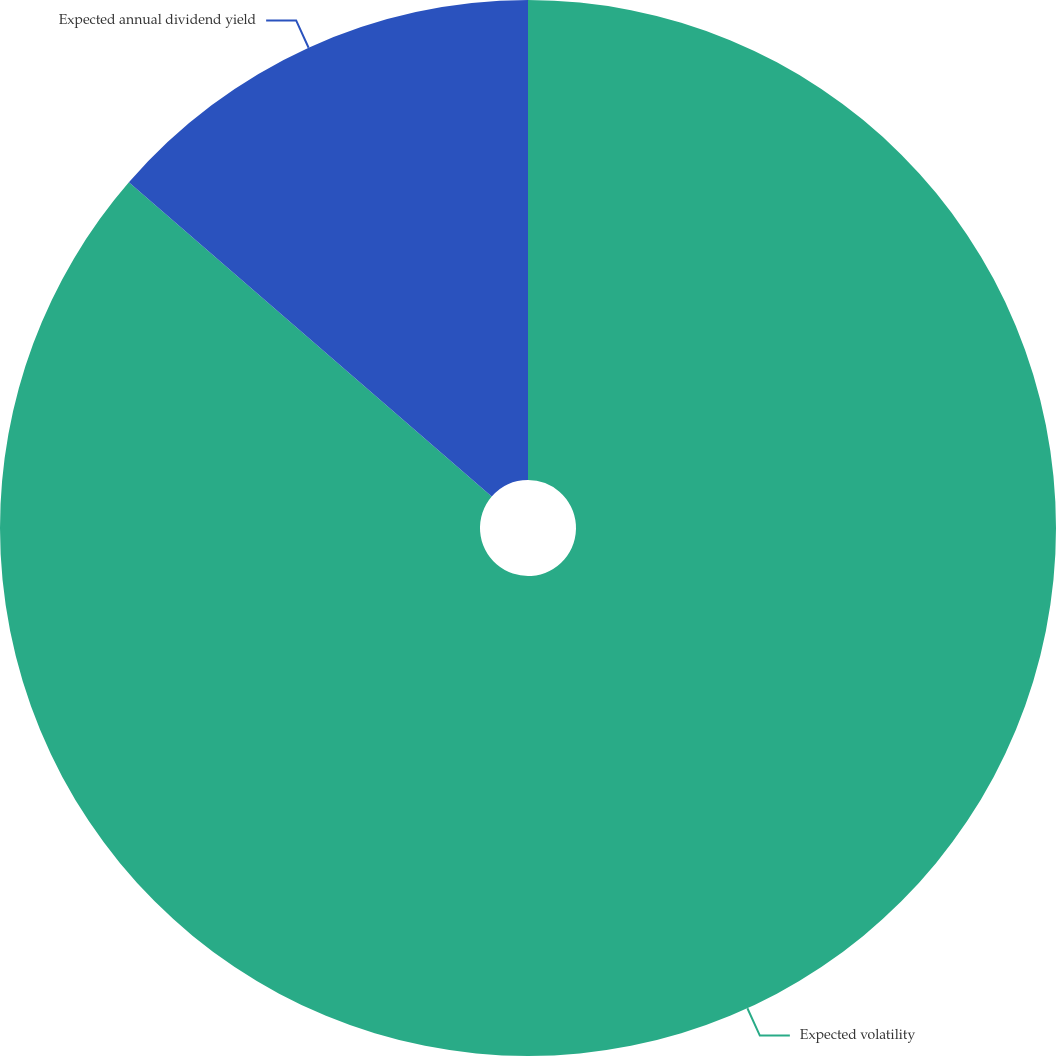<chart> <loc_0><loc_0><loc_500><loc_500><pie_chart><fcel>Expected volatility<fcel>Expected annual dividend yield<nl><fcel>86.36%<fcel>13.64%<nl></chart> 